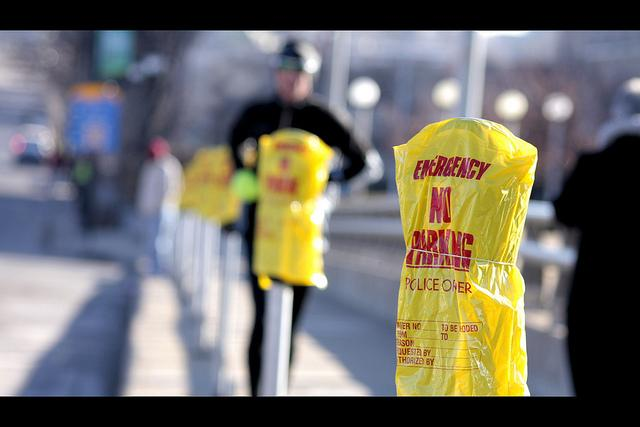What might be happening on this street? emergency 